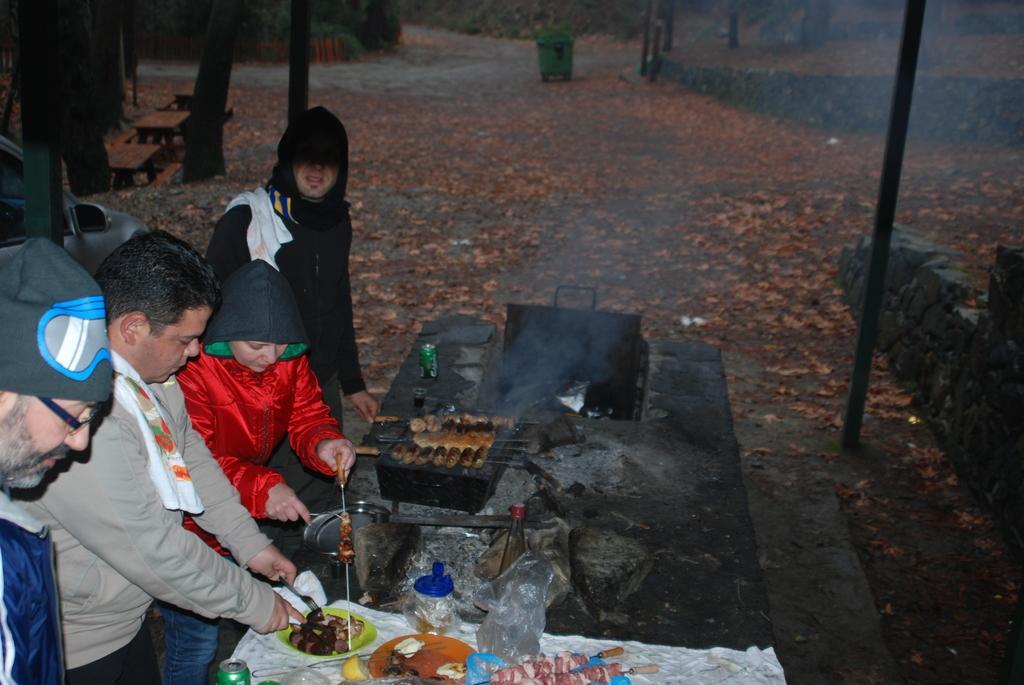Please provide a concise description of this image. In this picture we can observe some people sitting in front of a black color table. We can observe a grill on the table. There is some food places in the plates. We can observe a jar and a white color cloth on the table. There are two members who are wearing hoodies. In the background we can observe some dried leaves, green color trash bin and a road here. There is a pole on the right side. 